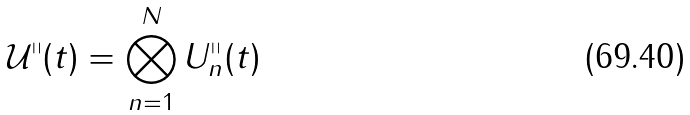Convert formula to latex. <formula><loc_0><loc_0><loc_500><loc_500>\mathcal { U } ^ { \shortparallel } ( t ) = \bigotimes _ { n = 1 } ^ { N } U _ { n } ^ { \shortparallel } ( t )</formula> 